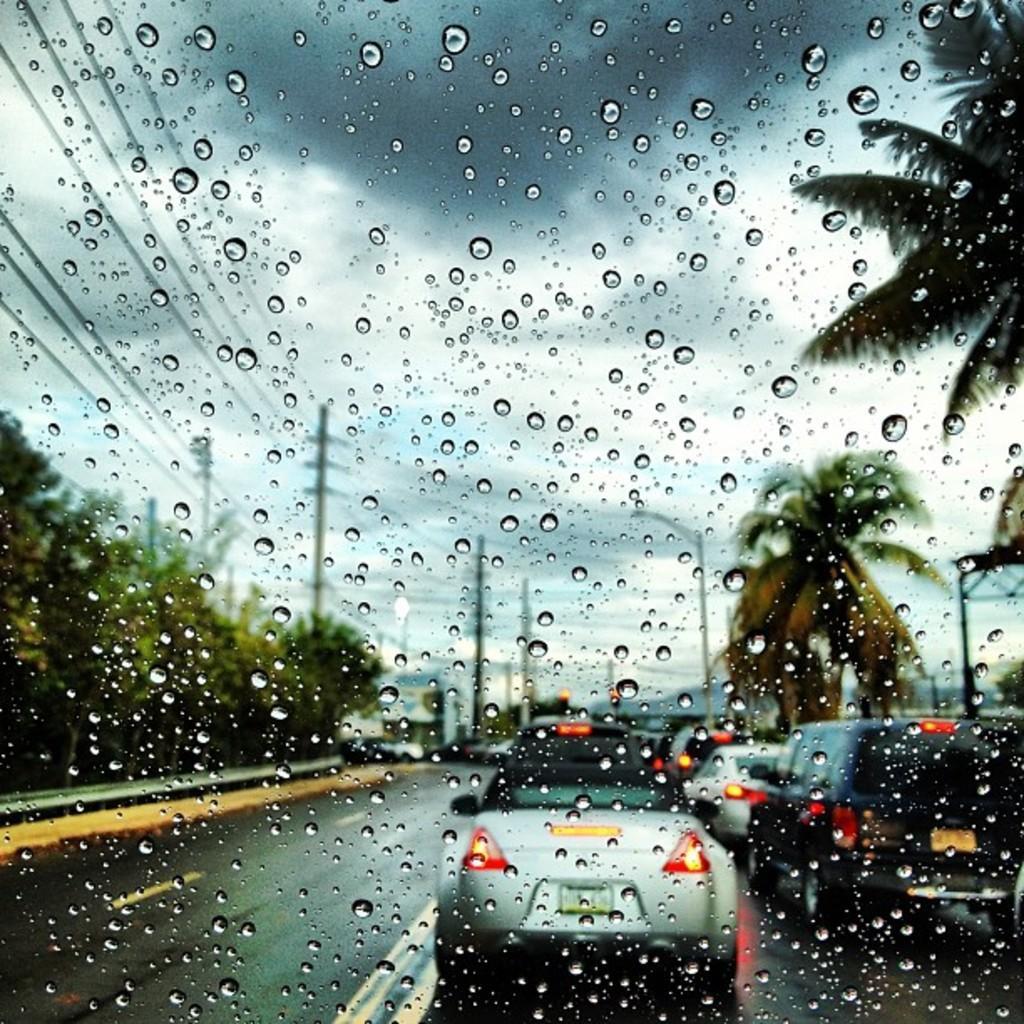Could you give a brief overview of what you see in this image? In this image I can see few water droplets, background I can see few vehicles on the road, trees in green color, few light poles and few electric poles and the sky is in white and gray color. 